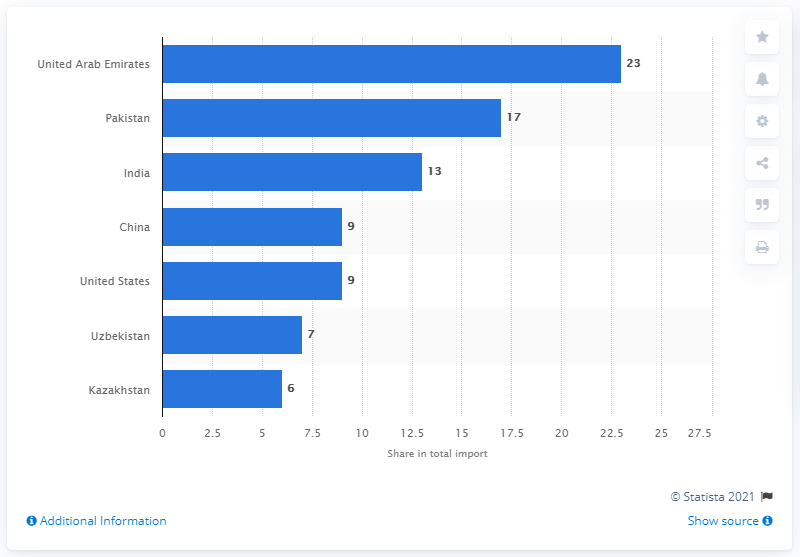Give some essential details in this illustration. In 2019, the United Arab Emirates was Afghanistan's most important import partner, accounting for a significant share of the country's total import volume. In 2019, Afghanistan's imports from the United Arab Emirates accounted for approximately 23% of its total imports. 